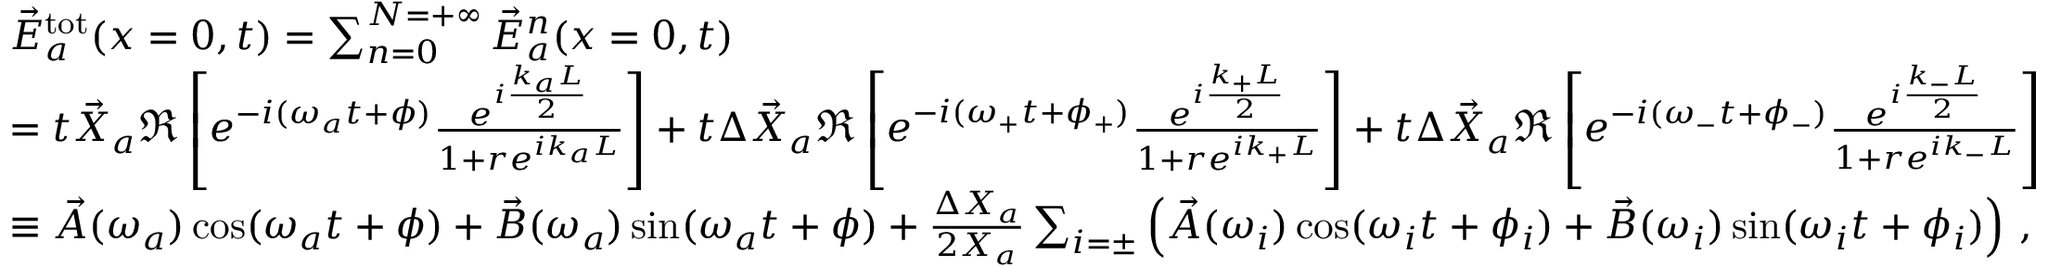Convert formula to latex. <formula><loc_0><loc_0><loc_500><loc_500>\begin{array} { r l } & { \vec { E } _ { a } ^ { t o t } ( x = 0 , t ) = \sum _ { n = 0 } ^ { N = + \infty } \vec { E } _ { a } ^ { n } ( x = 0 , t ) \, } \\ & { = t \vec { X } _ { a } \Re \left [ e ^ { - i ( \omega _ { a } t + \phi ) } \frac { e ^ { i \frac { k _ { a } L } { 2 } } } { 1 + r e ^ { i k _ { a } L } } \right ] + t \Delta \vec { X } _ { a } \Re \left [ e ^ { - i ( \omega _ { + } t + \phi _ { + } ) } \frac { e ^ { i \frac { k _ { + } L } { 2 } } } { 1 + r e ^ { i k _ { + } L } } \right ] + t \Delta \vec { X } _ { a } \Re \left [ e ^ { - i ( \omega _ { - } t + \phi _ { - } ) } \frac { e ^ { i \frac { k _ { - } L } { 2 } } } { 1 + r e ^ { i k _ { - } L } } \right ] \, } \\ & { \equiv \vec { A } ( \omega _ { a } ) \cos ( \omega _ { a } t + \phi ) + \vec { B } ( \omega _ { a } ) \sin ( \omega _ { a } t + \phi ) + \frac { \Delta X _ { a } } { 2 X _ { a } } \sum _ { i = \pm } \left ( \vec { A } ( \omega _ { i } ) \cos ( \omega _ { i } t + \phi _ { i } ) + \vec { B } ( \omega _ { i } ) \sin ( \omega _ { i } t + \phi _ { i } ) \right ) \, , } \end{array}</formula> 